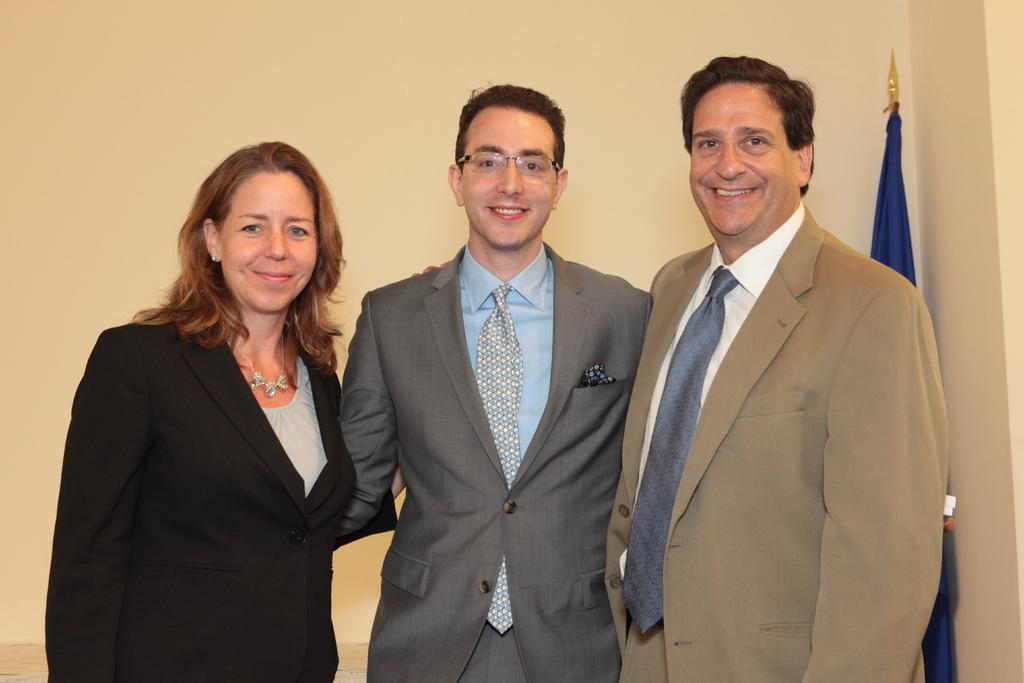How many people are present in the image? There are three people in the image. What expressions do the people have on their faces? The people are wearing smiles on their faces. Where is the flag located in the image? The flag is on the right side of the image. What can be seen in the background of the image? There is a wall in the background of the image. What type of fowl can be seen perched on the wall in the image? There is no fowl present on the wall in the image. Can you tell me how many stamps are on the flag in the image? There are no stamps on the flag in the image; it is a regular flag without any additional markings. 